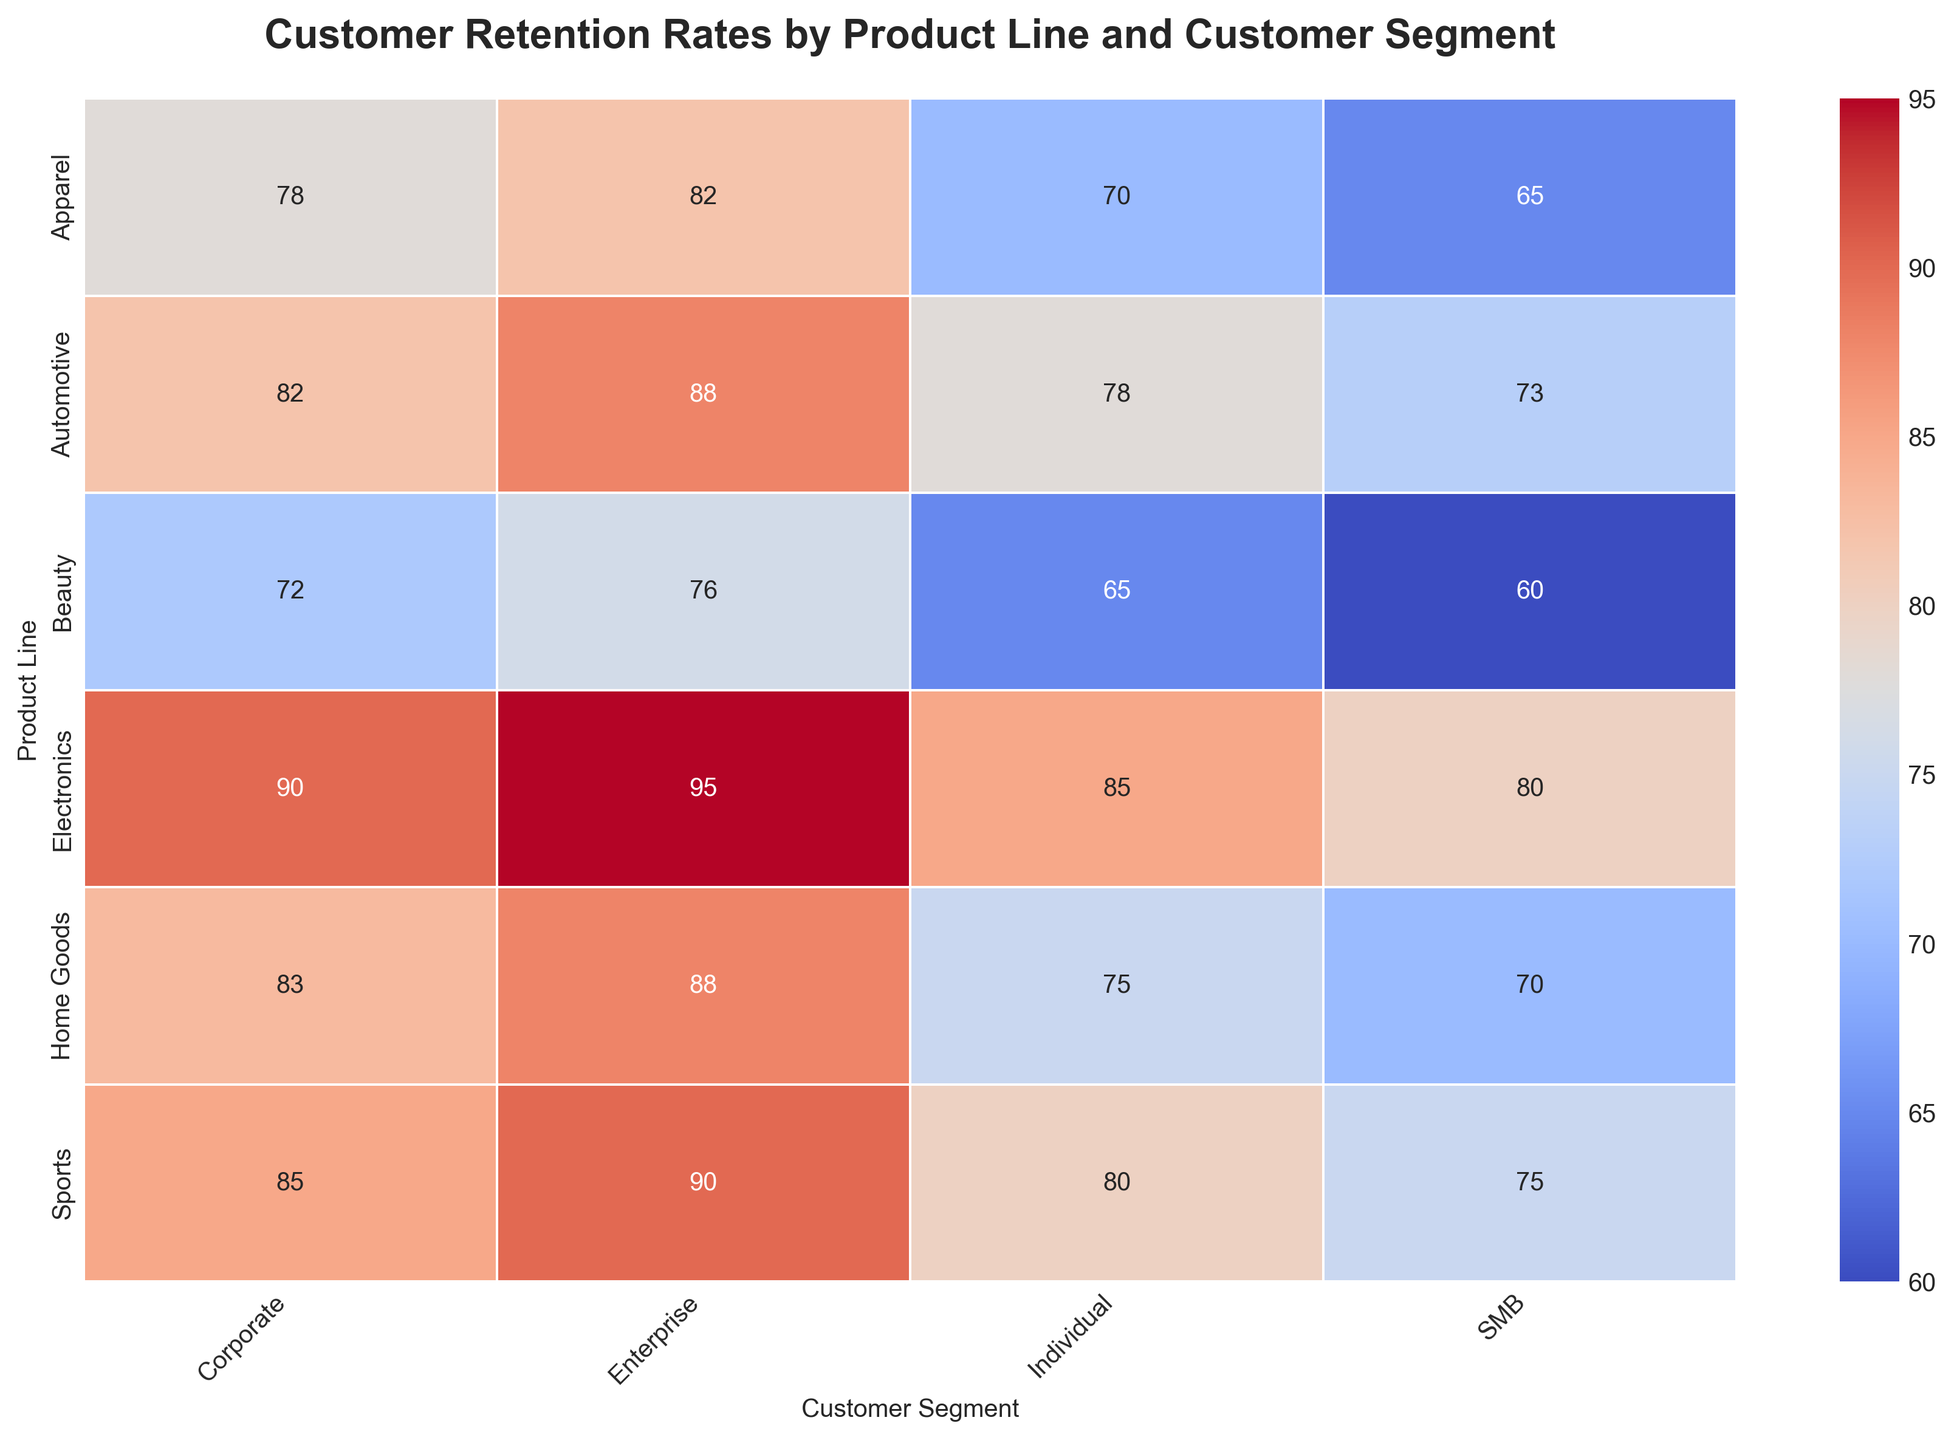What's the highest retention rate for the Electronics product line? The highest retention rate for the Electronics product line can be found by looking at the highest value in the row corresponding to the Electronics product line. The values are 85, 90, 80, and 95.
Answer: 95 Which customer segment has the lowest retention rate for the Apparel product line? The lowest retention rate for the Apparel product line can be found by looking at the smallest value in the row corresponding to Apparel. The values are 70, 78, 65, and 82.
Answer: SMB Does the Corporate segment generally show higher retention rates compared to the Individual segment across all product lines? To determine this, we need to compare the retention rates of the Corporate and Individual segments across each product line. For Electronics, Corporate (90) > Individual (85); for Apparel, Corporate (78) > Individual (70); for Home Goods, Corporate (83) > Individual (75); for Beauty, Corporate (72) > Individual (65); for Sports, Corporate (85) > Individual (80); for Automotive, Corporate (82) > Individual (78).
Answer: Yes Which product line has the most consistent retention rates across all customer segments? Consistency in retention rates can be evaluated by looking at the range (difference between highest and lowest values) within each product line. Electronics ranges from 80 to 95 (15), Apparel from 65 to 82 (17), Home Goods from 70 to 88 (18), Beauty from 60 to 76 (16), Sports from 75 to 90 (15), Automotive from 73 to 88 (15). The Electronics, Sports, and Automotive ranges are tied.
Answer: Electronics, Sports, Automotive What is the average retention rate for the Beauty product line across all customer segments? To find the average retention rate, sum all retention rates of the Beauty product line and divide by the number of segments. The values are 65, 72, 60, and 76. Sum = 273. Average = 273 / 4.
Answer: 68.25 How does the retention rate for SMB customers in the Sports product line compare to the same segment in the Home Goods product line? Compare the retention rate for SMB customers in Sports (75) with the retention rate for SMB customers in Home Goods (70).
Answer: Higher What is the combined retention rate for Individual and Corporate segments in the Electronics product line? Sum the retention rates for the Individual (85) and Corporate (90) segments in the Electronics product line.
Answer: 175 Which product line has the highest retention rate for the Enterprise segment? Look at the highest retention rate for the Enterprise segment across all product lines. Values are: Electronics (95), Apparel (82), Home Goods (88), Beauty (76), Sports (90), Automotive (88).
Answer: Electronics Are there any product lines where the Individual segment has a higher retention rate than the SMB segment? Compare the retention rates of the Individual and SMB segments across product lines. Electronics: Individual (85) > SMB (80); Apparel: Individual (70) > SMB (65); Home Goods: Individual (75) > SMB (70); Beauty: Individual (65) > SMB (60); Sports: Individual (80) > SMB (75); Automotive: Individual (78) > SMB (73).
Answer: Yes What is the difference in retention rates between the highest and lowest customer segments in the Automotive product line? To find this difference, identify the highest (Enterprise, 88) and lowest (SMB, 73) retention rates in the Automotive product line. Subtract the smallest from the largest.
Answer: 15 